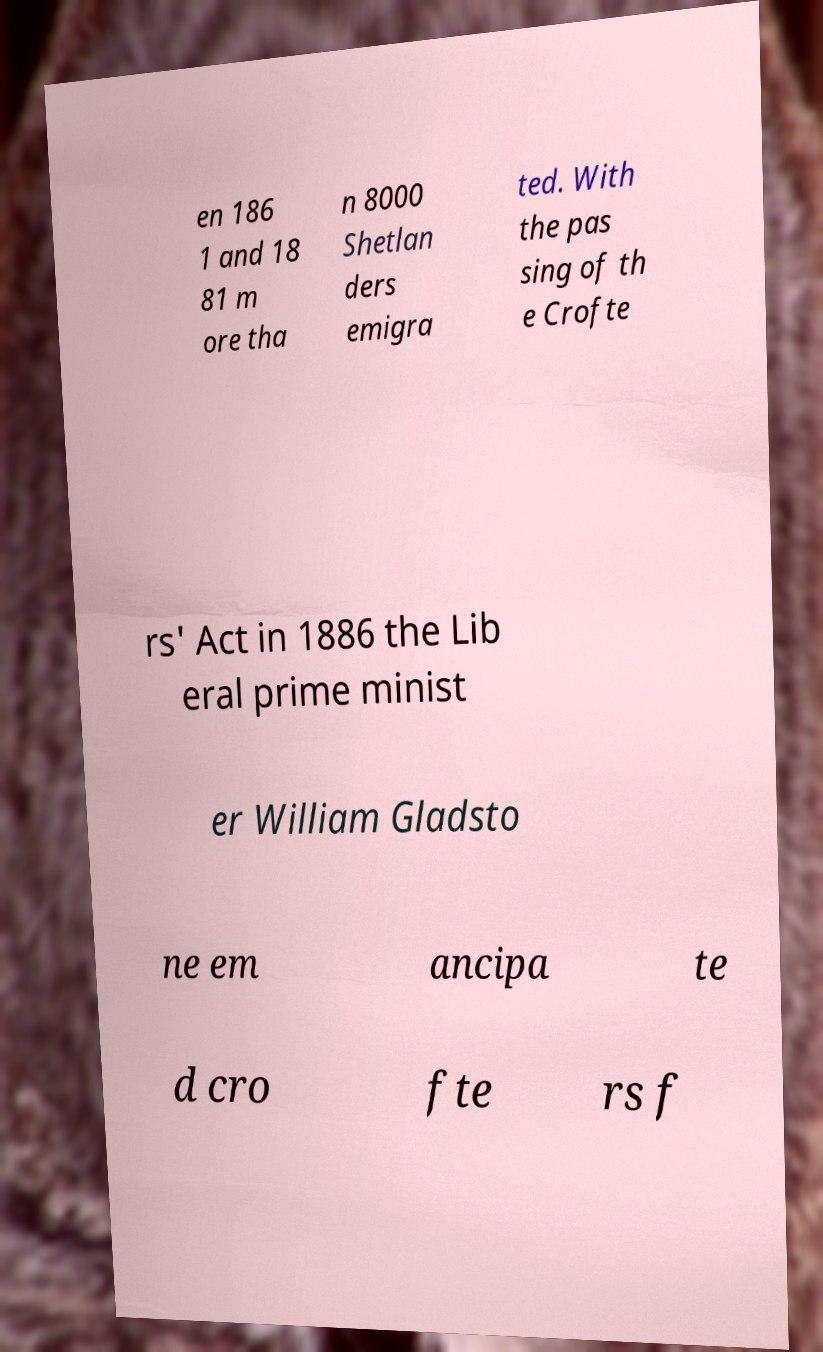Please identify and transcribe the text found in this image. en 186 1 and 18 81 m ore tha n 8000 Shetlan ders emigra ted. With the pas sing of th e Crofte rs' Act in 1886 the Lib eral prime minist er William Gladsto ne em ancipa te d cro fte rs f 